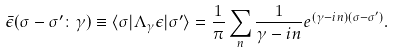Convert formula to latex. <formula><loc_0><loc_0><loc_500><loc_500>\bar { \epsilon } ( \sigma - \sigma ^ { \prime } \colon \gamma ) \equiv \langle \sigma | \Lambda _ { \gamma } \epsilon | \sigma ^ { \prime } \rangle = \frac { 1 } { \pi } \sum _ { n } \frac { 1 } { \gamma - i n } e ^ { ( \gamma - i n ) ( \sigma - \sigma ^ { \prime } ) } .</formula> 